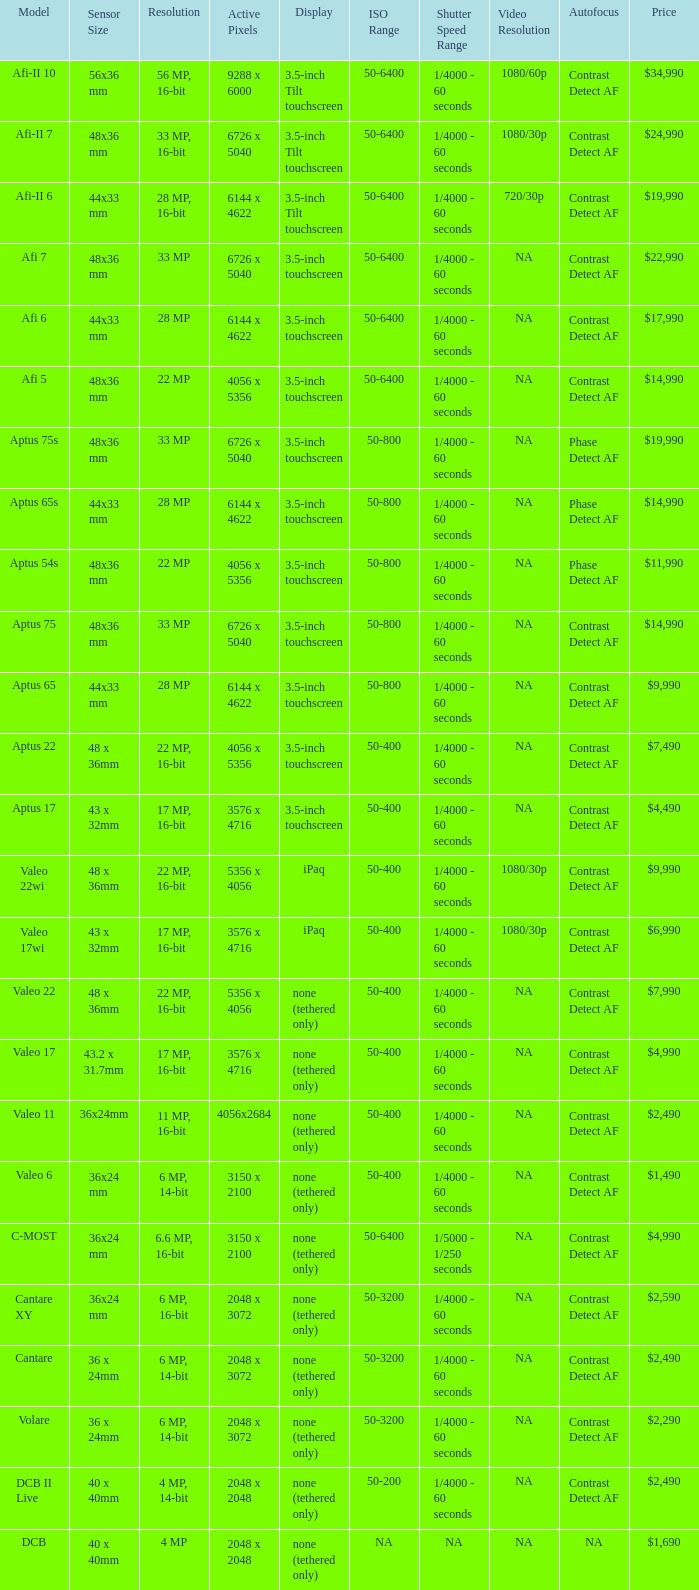What is the resolution of the camera that has 6726 x 5040 pixels and a model of afi 7? 33 MP. 